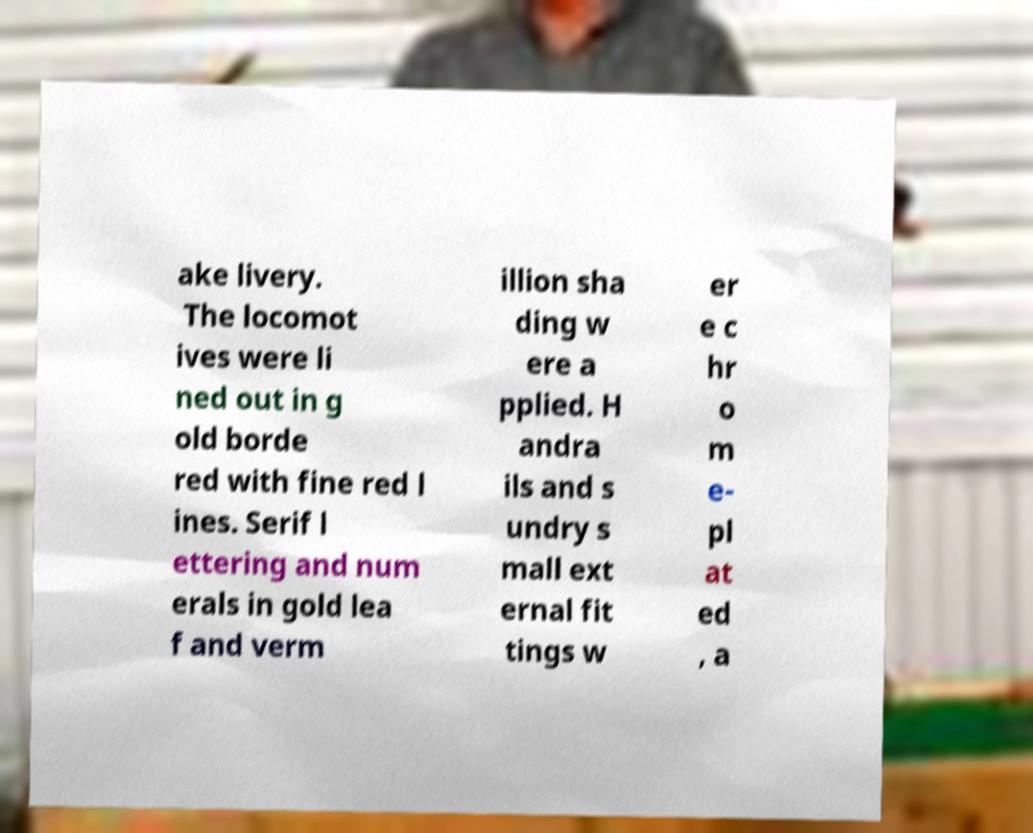There's text embedded in this image that I need extracted. Can you transcribe it verbatim? ake livery. The locomot ives were li ned out in g old borde red with fine red l ines. Serif l ettering and num erals in gold lea f and verm illion sha ding w ere a pplied. H andra ils and s undry s mall ext ernal fit tings w er e c hr o m e- pl at ed , a 